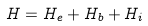<formula> <loc_0><loc_0><loc_500><loc_500>H = H _ { e } + H _ { b } + H _ { i }</formula> 